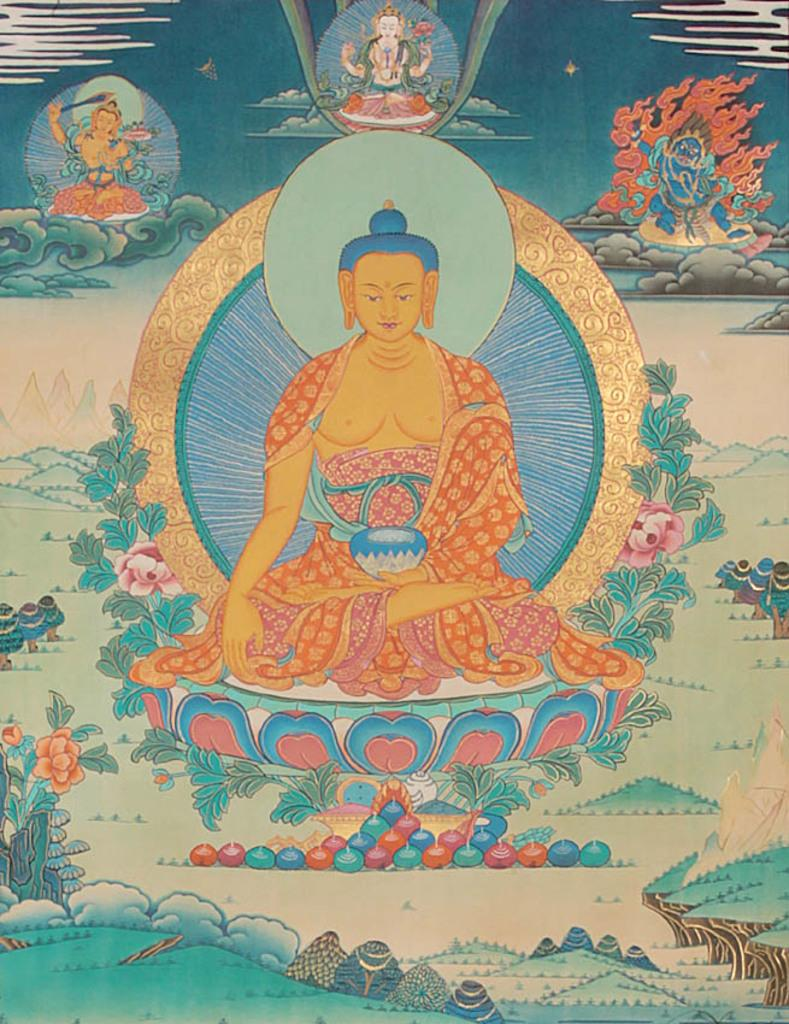What is the main subject of the image? The main subject of the image is an art piece. Can you describe the art piece in more detail? The art piece contains multiple images. How does the bat contribute to the comfort of the art piece in the image? There is no bat present in the image, and therefore it cannot contribute to the comfort of the art piece. 